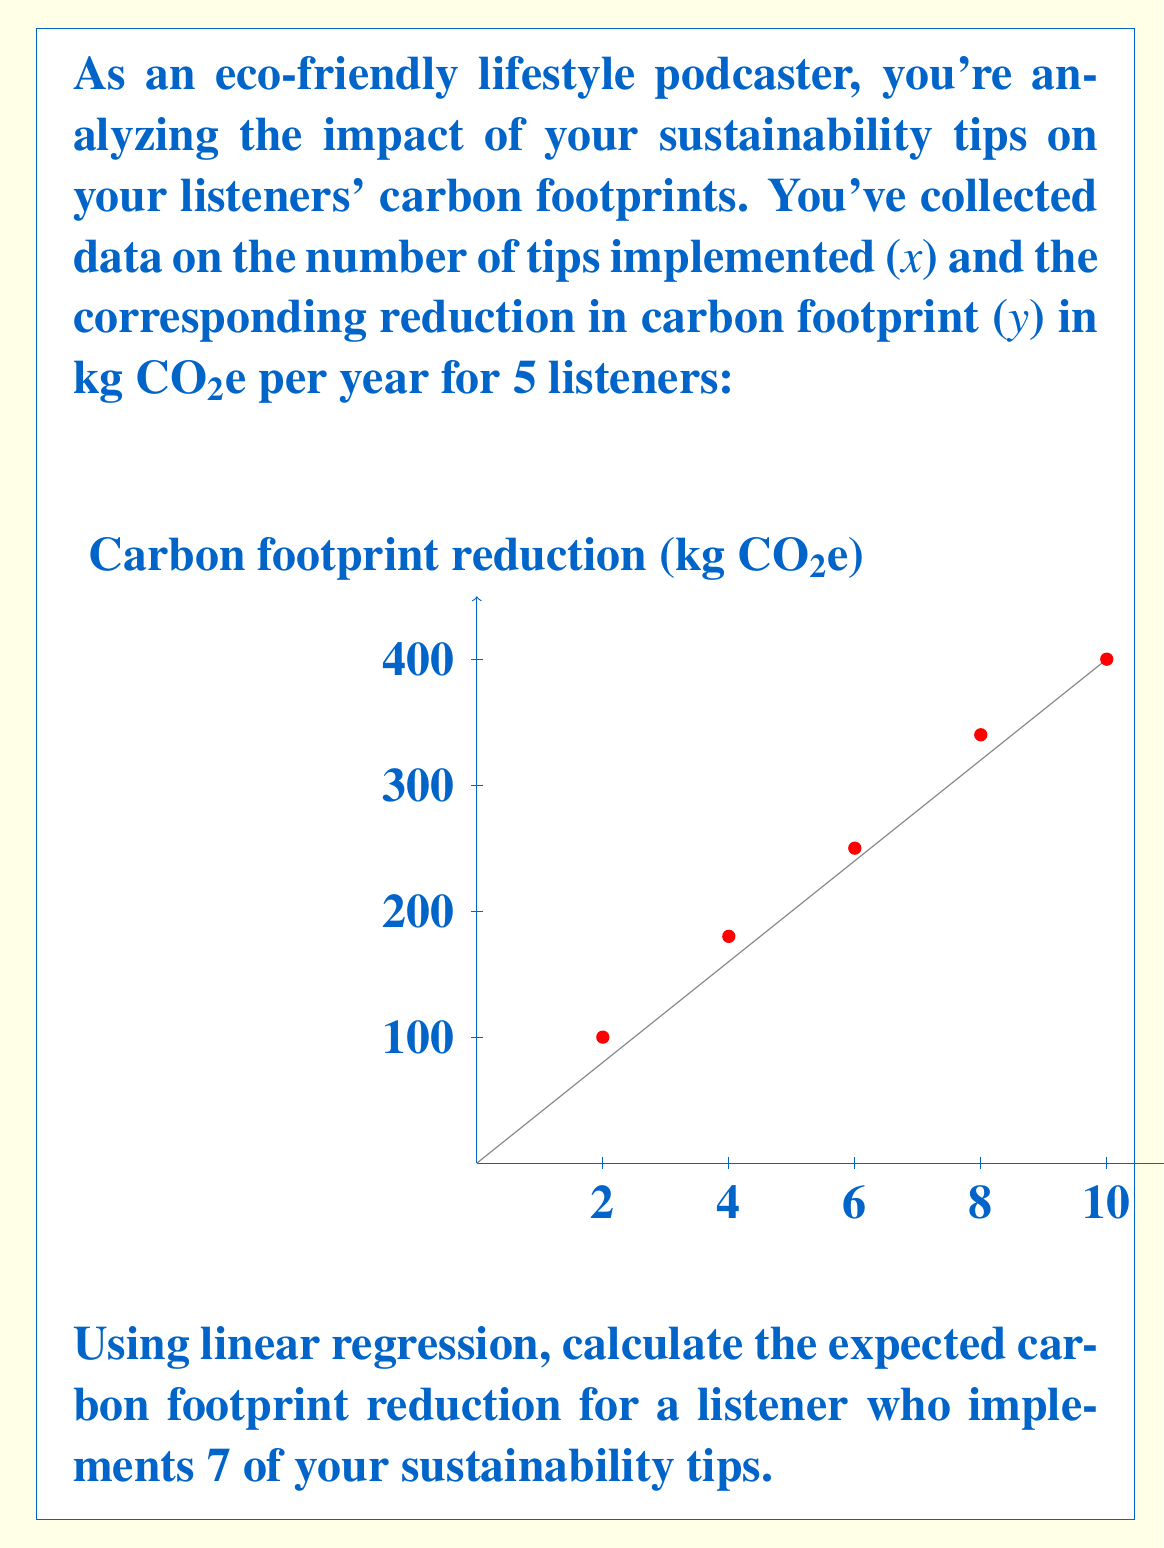Solve this math problem. To solve this problem using linear regression, we'll follow these steps:

1) First, we need to calculate the coefficients of the linear regression equation:
   $y = mx + b$

2) For this, we'll use the following formulas:
   $m = \frac{n\sum xy - \sum x \sum y}{n\sum x^2 - (\sum x)^2}$
   $b = \frac{\sum y - m\sum x}{n}$

   Where n is the number of data points (5 in this case).

3) Let's calculate the required sums:
   $\sum x = 2 + 4 + 6 + 8 + 10 = 30$
   $\sum y = 100 + 180 + 250 + 340 + 400 = 1270$
   $\sum xy = 2(100) + 4(180) + 6(250) + 8(340) + 10(400) = 8900$
   $\sum x^2 = 2^2 + 4^2 + 6^2 + 8^2 + 10^2 = 220$

4) Now we can calculate m:
   $m = \frac{5(8900) - 30(1270)}{5(220) - 30^2} = \frac{44500 - 38100}{1100 - 900} = \frac{6400}{200} = 32$

5) And b:
   $b = \frac{1270 - 32(30)}{5} = \frac{1270 - 960}{5} = 62$

6) Our linear regression equation is thus:
   $y = 32x + 62$

7) To find the expected carbon footprint reduction for 7 tips, we substitute x = 7:
   $y = 32(7) + 62 = 224 + 62 = 286$

Therefore, the expected carbon footprint reduction for a listener who implements 7 tips is 286 kg CO2e per year.
Answer: 286 kg CO2e 